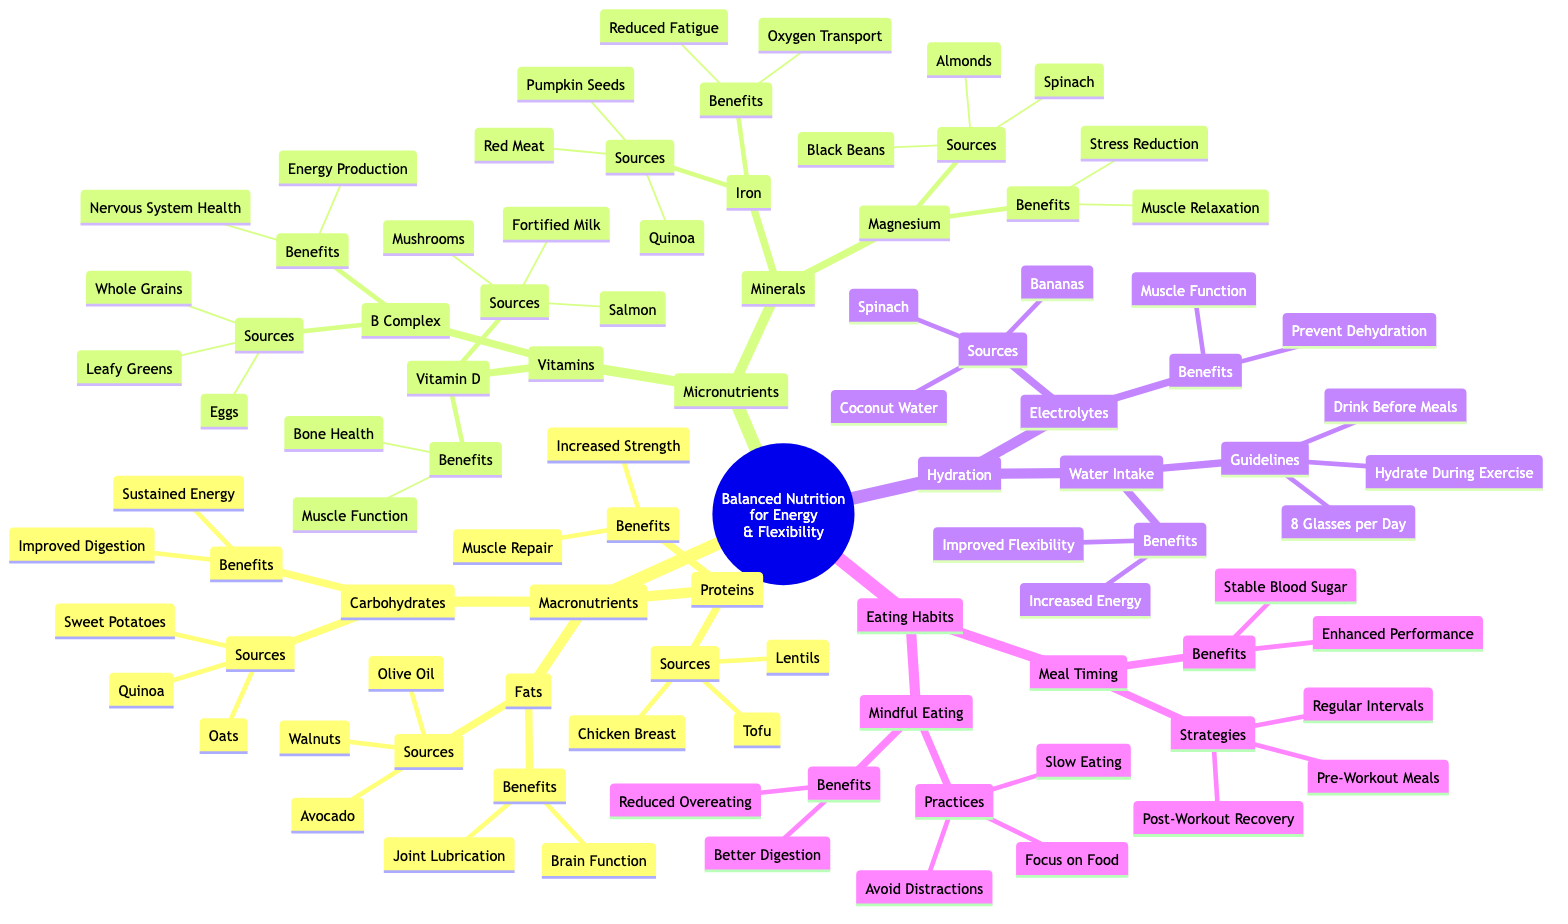What are three sources of carbohydrates? The diagram lists the sources under the 'Carbohydrates' node. The three sources mentioned are Quinoa, Sweet Potatoes, and Oats.
Answer: Quinoa, Sweet Potatoes, Oats What benefits are associated with proteins? The 'Proteins' node details the benefits related to proteins. It includes Muscle Repair and Increased Strength.
Answer: Muscle Repair, Increased Strength How many sources of vitamins are listed? The 'Vitamins' node contains two types of vitamins, Vitamin B Complex and Vitamin D. Each type has its respective sources, meaning there are two main nodes under the Vitamins category.
Answer: 2 What is the primary benefit of magnesium? The diagram under the 'Magnesium' node shows the benefits, which state Muscle Relaxation and Stress Reduction. Therefore, one primary benefit is Muscle Relaxation.
Answer: Muscle Relaxation What is the guideline for daily water intake? Looking under 'Hydration' and then 'Water Intake', the guideline specifies that one should drink 8 Glasses per Day.
Answer: 8 Glasses per Day What is the focus of mindful eating practices? The 'Mindful Eating' node outlines practices including Slow Eating, Focus on Food, and Avoid Distractions. It emphasizes focusing on food during meals.
Answer: Focus on Food What are two sources of electrolytes? The 'Electrolytes' node lists sources under it. The sources include Coconut Water, Bananas, and Spinach. Thus, two sources can be Coconut Water and Bananas.
Answer: Coconut Water, Bananas What is a strategy for meal timing? Under the 'Meal Timing' node, several strategies are provided, including Regular Intervals, Pre-Workout Meals, and Post-Workout Recovery. Any of these can be considered a strategy.
Answer: Regular Intervals 